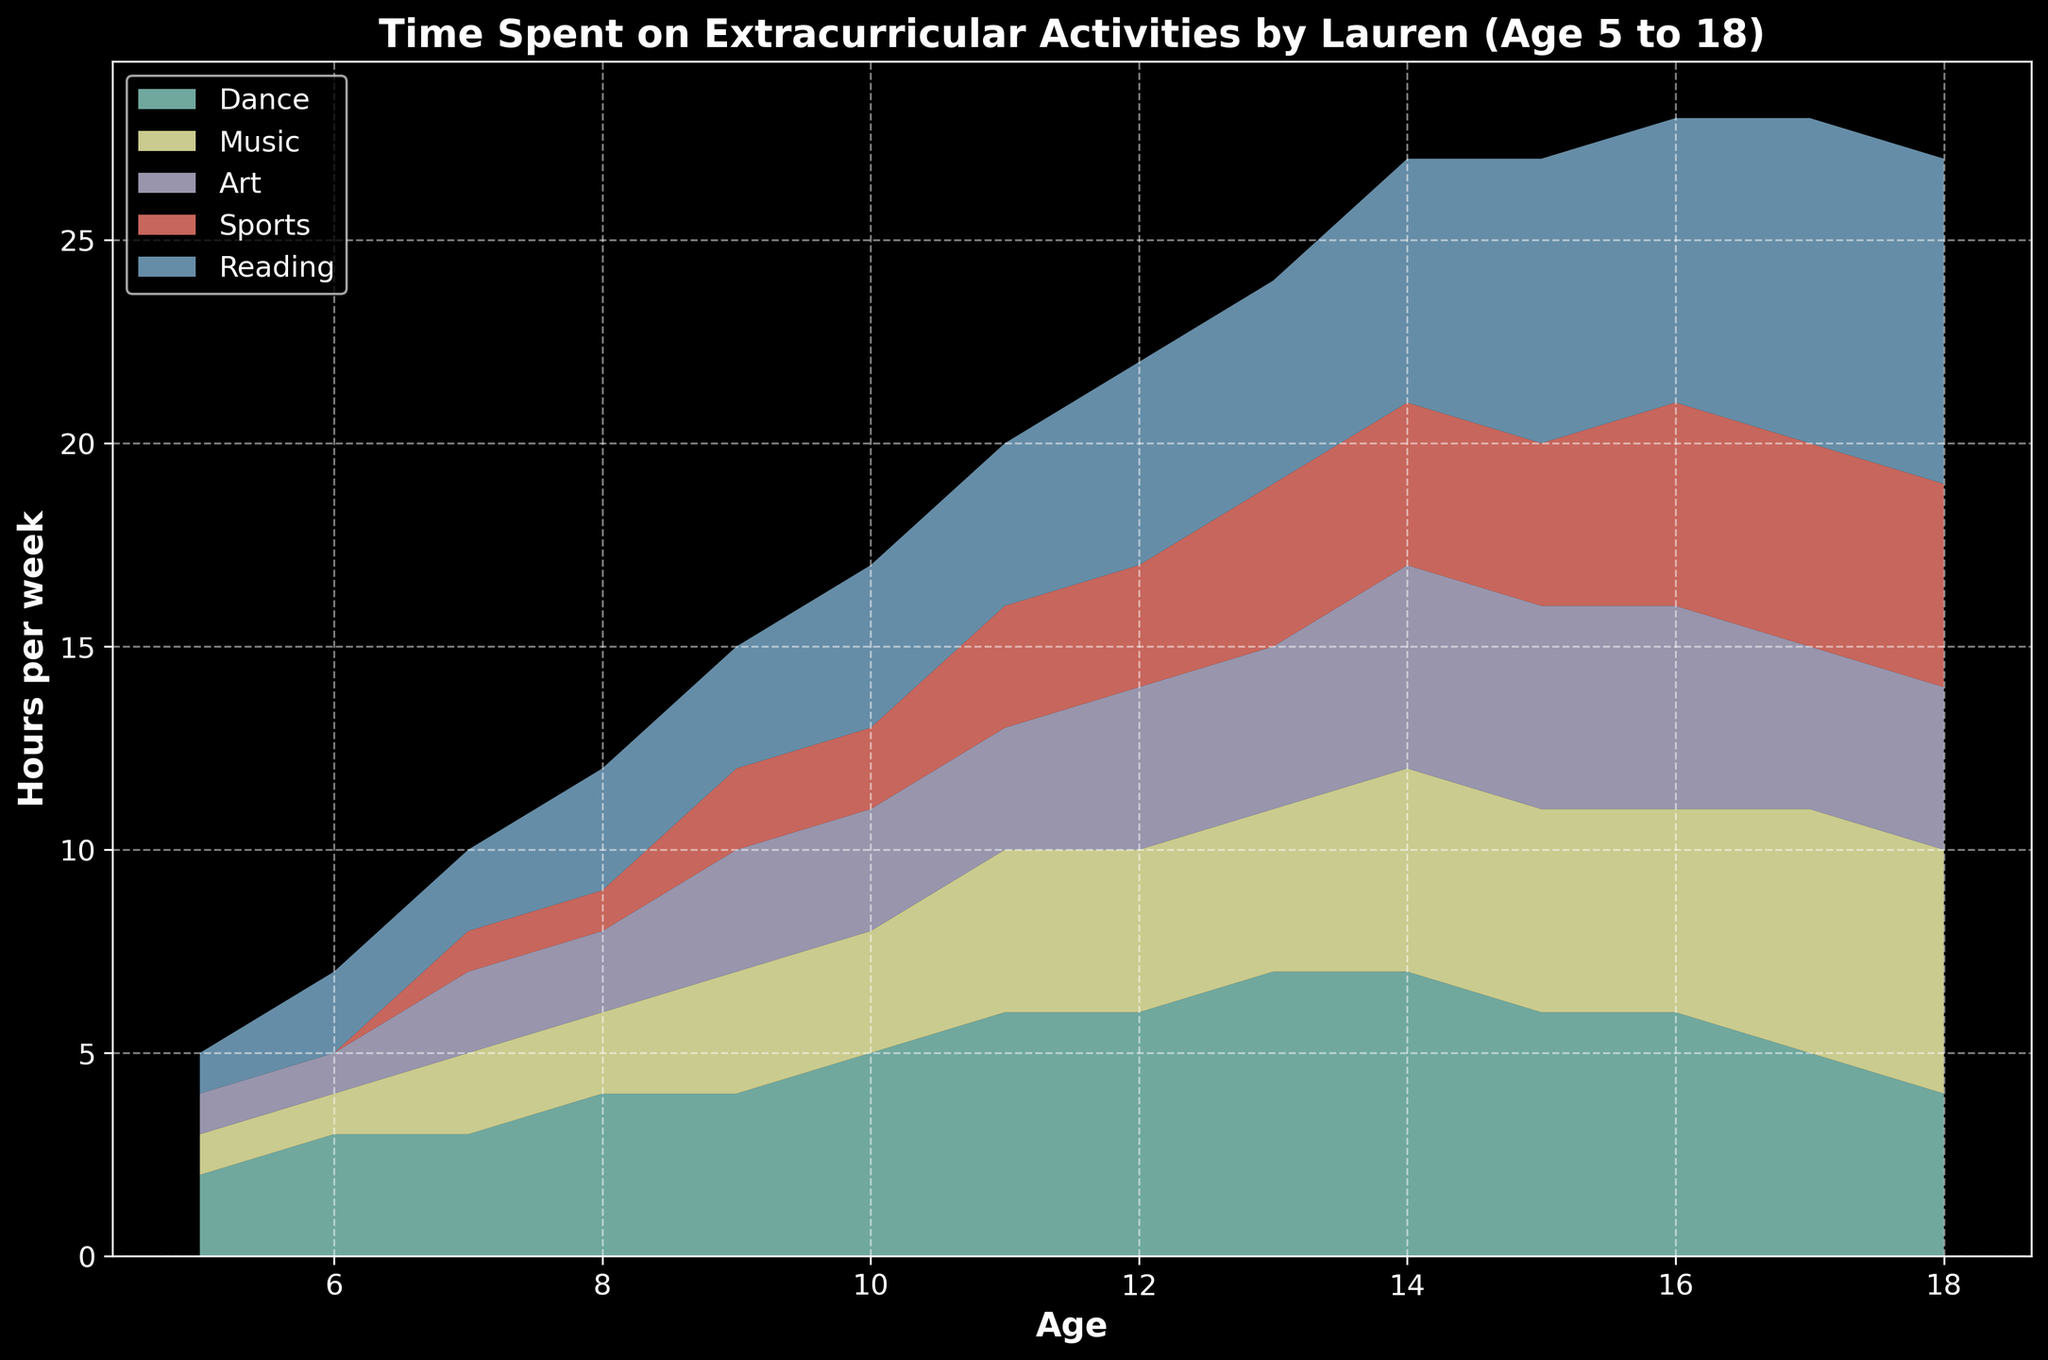what age did Lauren start spending time on sports? Look at the beginning of the sports area in the chart. The first non-zero value appears at age 7.
Answer: 7 Which activity did Lauren spend the most time on at age 10? Observe the heights of different areas at age 10. The area for "Dance" is the tallest.
Answer: Dance How does the time spent on music change from age 5 to age 18? Observe the area corresponding to "Music" from age 5 to 18. It gradually increases from 1 hour to 6 hours per week.
Answer: Gradual increase At what age did Lauren start spending more time on reading compared to Dance? Compare the areas for "Reading" and "Dance". At age 17, the area for "Reading" becomes larger than "Dance".
Answer: 17 What is the total time Lauren spent on all activities per week at age 15? Sum the heights of all areas at age 15 for Dance (6), Music (5), Art (5), Sports (4), and Reading (7). 6 + 5 + 5 + 4 + 7 = 27
Answer: 27 Which activity had the smallest increase in time spent from age 5 to age 18? Compare the areas over time. Art starts at 1 and increases to 4. Reading increases more significantly.
Answer: Art By age 13, did Lauren spend more time on sports or music, and by how much? Compare the areas at age 13. Sports is 4, Music is 4. So, they are the same.
Answer: Same At what age did Lauren start spending 5 or more hours a week on both dance and reading? Look at the areas for "Dance" and "Reading". At age 14, both exceed 5 hours.
Answer: 14 What is the average time Lauren spent on art from age 10 to age 15? Sum the values for Art from age 10-15 (3, 3, 4, 4, 5, 5) and divide by the number of years (6). (3 + 3 + 4 + 4 + 5 + 5)/6 = 4
Answer: 4 What visual trend can you observe about Lauren's time spent on dance from age 16 to age 18? Observe the height of the "Dance" area from age 16 to 18. It decreases from 6 to 5, then to 4.
Answer: Decreasing 